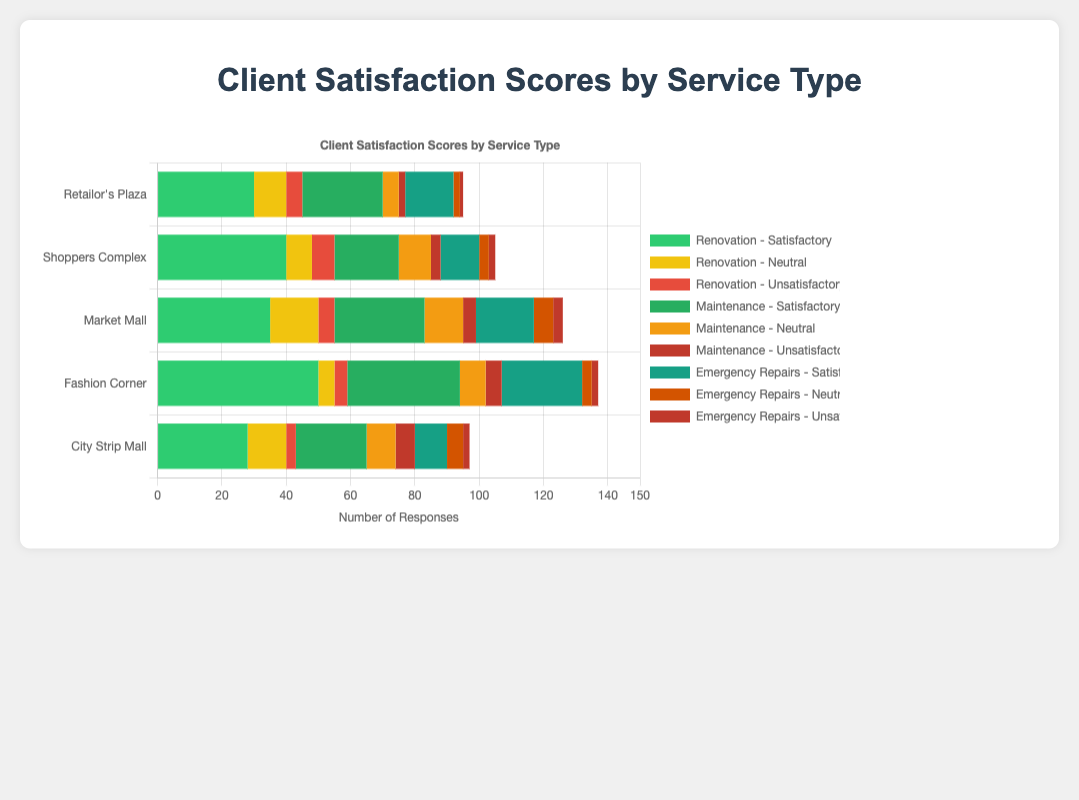Which client has the highest number of satisfactory Renovation responses? Fashion Corner has the highest number of satisfactory Renovation responses, at 50, as indicated by the length of the green bar corresponding to Renovation in the figure.
Answer: Fashion Corner What is the total number of satisfactory responses across all services for Shoppers Complex? For Shoppers Complex, sum the satisfactory responses for Renovation (40), Maintenance (20), and Emergency Repairs (12). The total is 40 + 20 + 12 = 72.
Answer: 72 Which service type received the highest number of neutral responses for Market Mall? For Market Mall, compare the lengths of the yellow bars for the neutral responses: Renovation (15), Maintenance (12), and Emergency Repairs (6). The highest number comes from Renovation, with 15 responses.
Answer: Renovation Which client has the lowest number of unsatisfactory Maintenance responses? City Strip Mall has the lowest number of unsatisfactory Maintenance responses, with 6 unsatisfactory responses, as indicated by the length of the red bar in the Maintenance category.
Answer: City Strip Mall How does the number of satisfactory responses for Emergency Repairs compare between Retailor's Plaza and Fashion Corner? Retailor's Plaza has 15 satisfactory responses for Emergency Repairs, while Fashion Corner has 25. Comparing these numbers, Fashion Corner has a higher number by 10 responses (25 - 15 = 10).
Answer: Fashion Corner has 10 more What is the sum of neutral responses for Emergency Repairs across all clients? Add the neutral responses for Emergency Repairs for all clients: Retailor's Plaza (2), Shoppers Complex (3), Market Mall (6), Fashion Corner (3), and City Strip Mall (5). The total sum is 2 + 3 + 6 + 3 + 5 = 19.
Answer: 19 Are there any clients with an equal number of satisfactory responses for Renovation and Maintenance? Compare the number of satisfactory responses for Renovation and Maintenance across all clients. Retailor's Plaza has 30 satisfactory responses for Renovation and 25 for Maintenance, which are not equal. Similarly, none of the other clients has an equal number. Thus, no clients have equal satisfactory responses for these services.
Answer: No Which service type has the shortest unsatisfactory bar for Retailor's Plaza? For Retailor's Plaza, compare the lengths of the red bars for unsatisfactory responses: Renovation (5), Maintenance (2), Emergency Repairs (1). The shortest bar is for Emergency Repairs, with 1 response.
Answer: Emergency Repairs What is the average number of neutral responses for Renovation across all clients? Calculate the average by summing the neutral Renovation responses for all clients and dividing by the number of clients: (10 + 8 + 15 + 5 + 12) / 5 = 50 / 5 = 10.
Answer: 10 